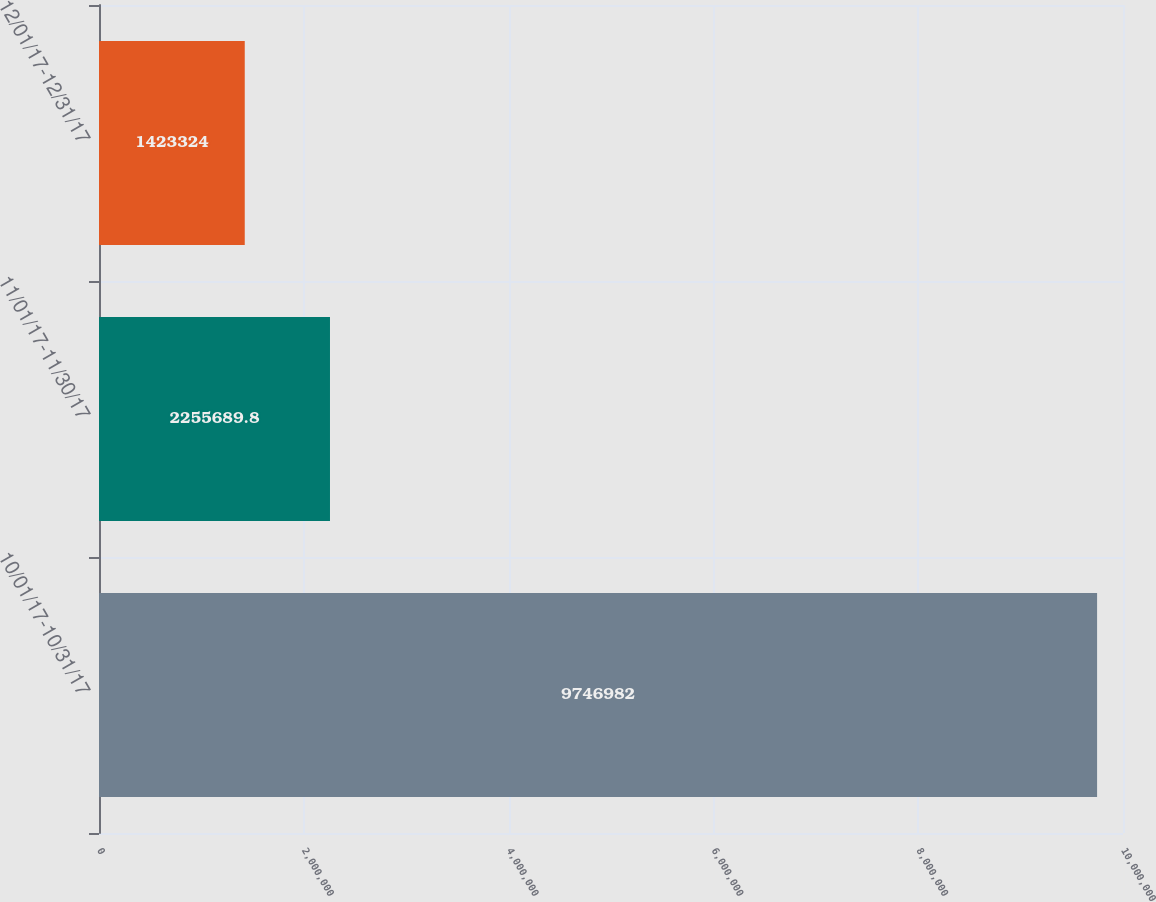Convert chart to OTSL. <chart><loc_0><loc_0><loc_500><loc_500><bar_chart><fcel>10/01/17-10/31/17<fcel>11/01/17-11/30/17<fcel>12/01/17-12/31/17<nl><fcel>9.74698e+06<fcel>2.25569e+06<fcel>1.42332e+06<nl></chart> 